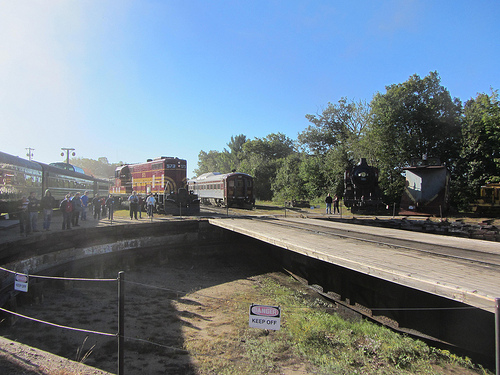What color do you think the train the people are standing by has? The train that the people are standing by appears to be black. 